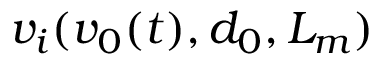Convert formula to latex. <formula><loc_0><loc_0><loc_500><loc_500>v _ { i } ( v _ { 0 } ( t ) , d _ { 0 } , L _ { m } )</formula> 